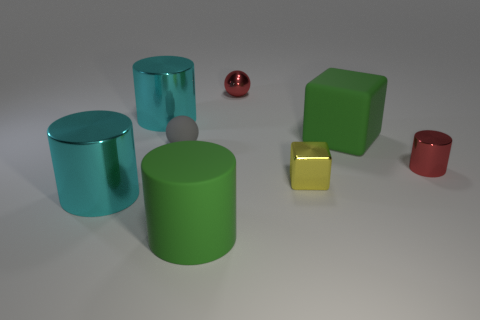Subtract all large green cylinders. How many cylinders are left? 3 Add 2 matte spheres. How many objects exist? 10 Subtract all yellow cubes. How many cubes are left? 1 Subtract all green cubes. How many cyan cylinders are left? 2 Subtract all cubes. How many objects are left? 6 Subtract 3 cylinders. How many cylinders are left? 1 Subtract all large cyan rubber blocks. Subtract all cyan metallic cylinders. How many objects are left? 6 Add 7 red things. How many red things are left? 9 Add 7 green rubber objects. How many green rubber objects exist? 9 Subtract 0 blue balls. How many objects are left? 8 